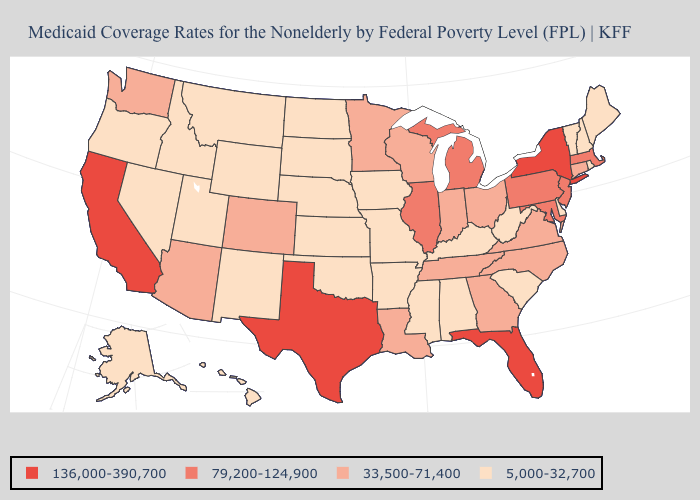Does New York have a higher value than Virginia?
Keep it brief. Yes. Name the states that have a value in the range 33,500-71,400?
Keep it brief. Arizona, Colorado, Connecticut, Georgia, Indiana, Louisiana, Minnesota, North Carolina, Ohio, Tennessee, Virginia, Washington, Wisconsin. Does the first symbol in the legend represent the smallest category?
Give a very brief answer. No. What is the value of Iowa?
Answer briefly. 5,000-32,700. Among the states that border Ohio , does Pennsylvania have the highest value?
Give a very brief answer. Yes. What is the highest value in states that border Alabama?
Quick response, please. 136,000-390,700. What is the value of New Jersey?
Keep it brief. 79,200-124,900. What is the lowest value in the West?
Concise answer only. 5,000-32,700. Among the states that border Nevada , does Arizona have the lowest value?
Give a very brief answer. No. What is the highest value in states that border Texas?
Be succinct. 33,500-71,400. Which states have the lowest value in the MidWest?
Short answer required. Iowa, Kansas, Missouri, Nebraska, North Dakota, South Dakota. Name the states that have a value in the range 136,000-390,700?
Give a very brief answer. California, Florida, New York, Texas. What is the lowest value in states that border Vermont?
Quick response, please. 5,000-32,700. What is the value of Maine?
Answer briefly. 5,000-32,700. What is the value of Washington?
Concise answer only. 33,500-71,400. 